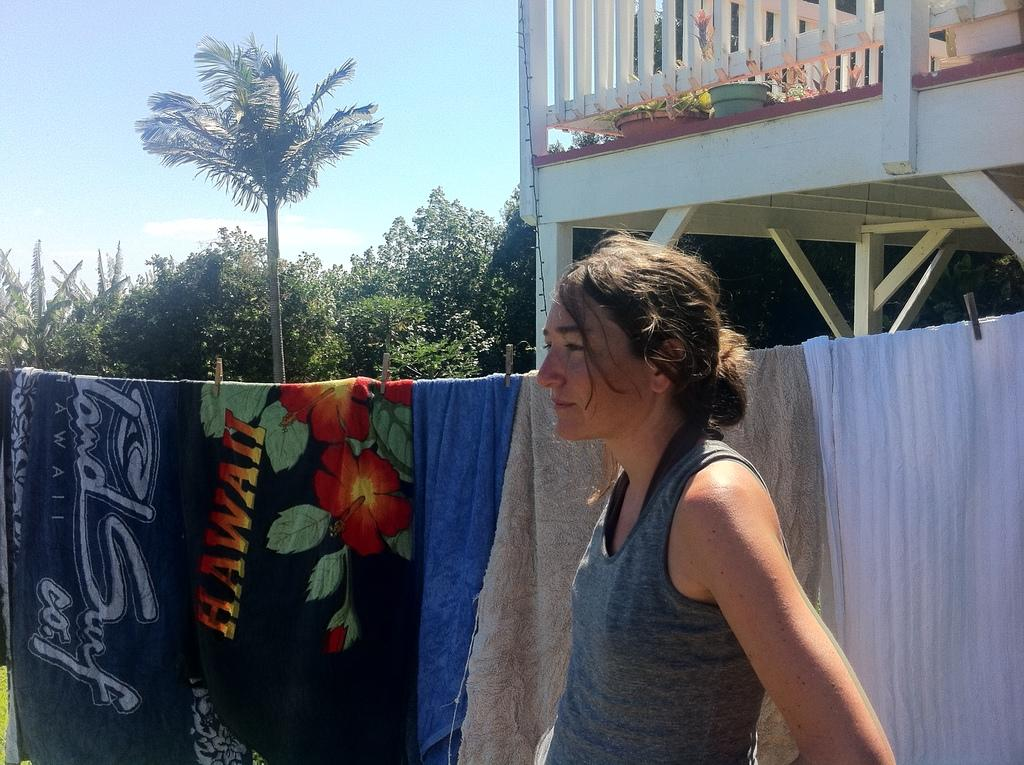What is the main subject in the image? There is a woman standing in the image. What can be seen in the background of the image? In the background of the image, there are clothespins, trees, wooden objects, plants, pots, railings, and the sky. Can you describe the wooden objects in the background? The wooden objects in the background are not specified, but they are mentioned as being present. What type of vegetation is visible in the background? Trees and plants are visible in the background of the image. What is the woman doing to make the plants spark in the image? There is no indication in the image that the plants are sparking, and the woman's actions are not described. 